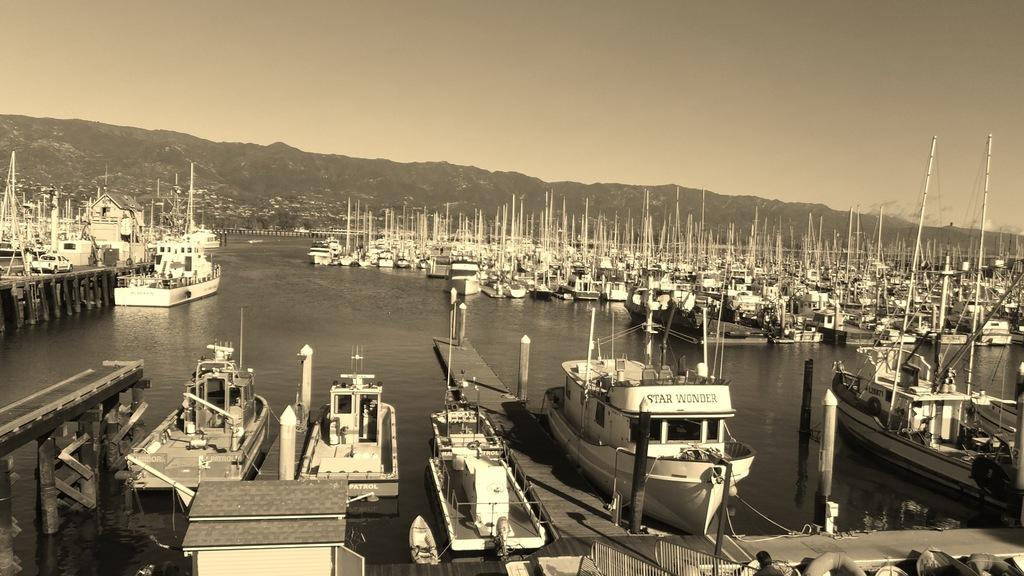What can be seen in the image that is used for transportation on water? There are boats in the image. What is the primary element in which the boats are situated? There is water visible in the image. What type of natural features can be seen in the background of the image? There are mountains and trees in the background of the image. What is visible at the top of the image? The sky is visible at the top of the image. What type of rhythm can be heard coming from the store in the image? There is no store present in the image, so it's not possible to determine what rhythm might be heard. Are there any ghosts visible in the image? There are no ghosts present in the image. 